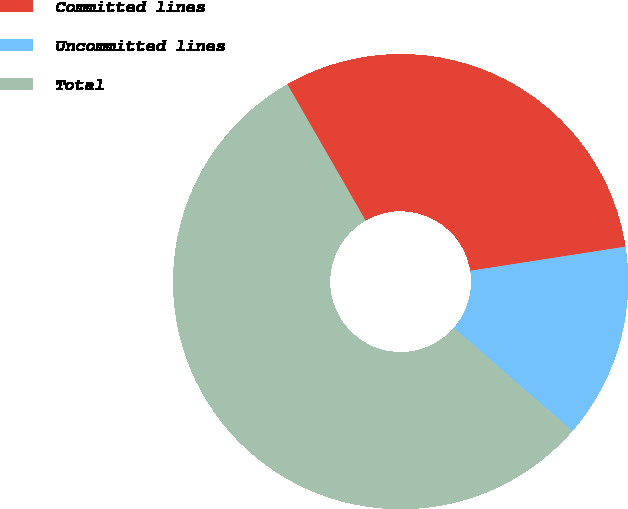<chart> <loc_0><loc_0><loc_500><loc_500><pie_chart><fcel>Committed lines<fcel>Uncommitted lines<fcel>Total<nl><fcel>30.84%<fcel>13.84%<fcel>55.31%<nl></chart> 